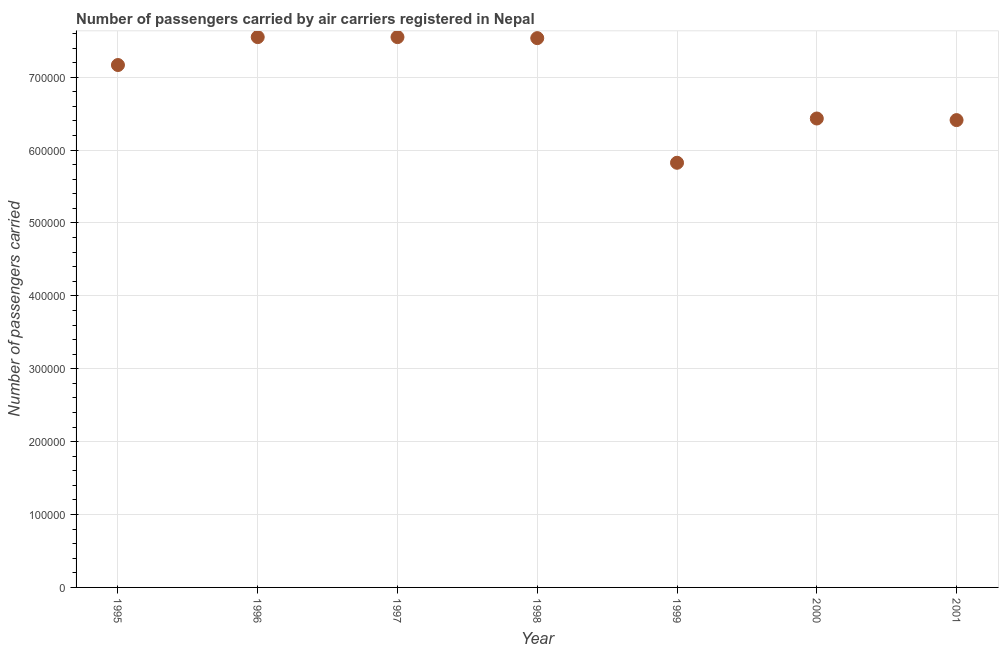What is the number of passengers carried in 2000?
Offer a terse response. 6.43e+05. Across all years, what is the maximum number of passengers carried?
Your response must be concise. 7.55e+05. Across all years, what is the minimum number of passengers carried?
Your answer should be very brief. 5.83e+05. In which year was the number of passengers carried maximum?
Keep it short and to the point. 1996. What is the sum of the number of passengers carried?
Your answer should be compact. 4.85e+06. What is the difference between the number of passengers carried in 1995 and 1997?
Give a very brief answer. -3.83e+04. What is the average number of passengers carried per year?
Ensure brevity in your answer.  6.92e+05. What is the median number of passengers carried?
Make the answer very short. 7.17e+05. Do a majority of the years between 2000 and 1997 (inclusive) have number of passengers carried greater than 620000 ?
Ensure brevity in your answer.  Yes. What is the ratio of the number of passengers carried in 1995 to that in 1999?
Provide a short and direct response. 1.23. Is the number of passengers carried in 1996 less than that in 1999?
Offer a very short reply. No. Is the difference between the number of passengers carried in 1996 and 2000 greater than the difference between any two years?
Your response must be concise. No. What is the difference between the highest and the second highest number of passengers carried?
Your answer should be very brief. 0. What is the difference between the highest and the lowest number of passengers carried?
Your answer should be very brief. 1.72e+05. Does the graph contain grids?
Provide a short and direct response. Yes. What is the title of the graph?
Keep it short and to the point. Number of passengers carried by air carriers registered in Nepal. What is the label or title of the X-axis?
Provide a succinct answer. Year. What is the label or title of the Y-axis?
Offer a very short reply. Number of passengers carried. What is the Number of passengers carried in 1995?
Offer a very short reply. 7.17e+05. What is the Number of passengers carried in 1996?
Provide a short and direct response. 7.55e+05. What is the Number of passengers carried in 1997?
Make the answer very short. 7.55e+05. What is the Number of passengers carried in 1998?
Make the answer very short. 7.54e+05. What is the Number of passengers carried in 1999?
Make the answer very short. 5.83e+05. What is the Number of passengers carried in 2000?
Ensure brevity in your answer.  6.43e+05. What is the Number of passengers carried in 2001?
Give a very brief answer. 6.41e+05. What is the difference between the Number of passengers carried in 1995 and 1996?
Provide a succinct answer. -3.83e+04. What is the difference between the Number of passengers carried in 1995 and 1997?
Your response must be concise. -3.83e+04. What is the difference between the Number of passengers carried in 1995 and 1998?
Provide a succinct answer. -3.69e+04. What is the difference between the Number of passengers carried in 1995 and 1999?
Offer a terse response. 1.34e+05. What is the difference between the Number of passengers carried in 1995 and 2000?
Offer a very short reply. 7.34e+04. What is the difference between the Number of passengers carried in 1995 and 2001?
Ensure brevity in your answer.  7.56e+04. What is the difference between the Number of passengers carried in 1996 and 1997?
Offer a very short reply. 0. What is the difference between the Number of passengers carried in 1996 and 1998?
Give a very brief answer. 1400. What is the difference between the Number of passengers carried in 1996 and 1999?
Your response must be concise. 1.72e+05. What is the difference between the Number of passengers carried in 1996 and 2000?
Offer a terse response. 1.12e+05. What is the difference between the Number of passengers carried in 1996 and 2001?
Make the answer very short. 1.14e+05. What is the difference between the Number of passengers carried in 1997 and 1998?
Your answer should be very brief. 1400. What is the difference between the Number of passengers carried in 1997 and 1999?
Make the answer very short. 1.72e+05. What is the difference between the Number of passengers carried in 1997 and 2000?
Your response must be concise. 1.12e+05. What is the difference between the Number of passengers carried in 1997 and 2001?
Your response must be concise. 1.14e+05. What is the difference between the Number of passengers carried in 1998 and 1999?
Keep it short and to the point. 1.71e+05. What is the difference between the Number of passengers carried in 1998 and 2000?
Your response must be concise. 1.10e+05. What is the difference between the Number of passengers carried in 1998 and 2001?
Your answer should be compact. 1.12e+05. What is the difference between the Number of passengers carried in 1999 and 2000?
Your answer should be compact. -6.07e+04. What is the difference between the Number of passengers carried in 1999 and 2001?
Give a very brief answer. -5.85e+04. What is the difference between the Number of passengers carried in 2000 and 2001?
Your answer should be very brief. 2190. What is the ratio of the Number of passengers carried in 1995 to that in 1996?
Offer a terse response. 0.95. What is the ratio of the Number of passengers carried in 1995 to that in 1997?
Your answer should be very brief. 0.95. What is the ratio of the Number of passengers carried in 1995 to that in 1998?
Give a very brief answer. 0.95. What is the ratio of the Number of passengers carried in 1995 to that in 1999?
Ensure brevity in your answer.  1.23. What is the ratio of the Number of passengers carried in 1995 to that in 2000?
Your response must be concise. 1.11. What is the ratio of the Number of passengers carried in 1995 to that in 2001?
Provide a short and direct response. 1.12. What is the ratio of the Number of passengers carried in 1996 to that in 1998?
Make the answer very short. 1. What is the ratio of the Number of passengers carried in 1996 to that in 1999?
Your answer should be compact. 1.3. What is the ratio of the Number of passengers carried in 1996 to that in 2000?
Give a very brief answer. 1.17. What is the ratio of the Number of passengers carried in 1996 to that in 2001?
Offer a terse response. 1.18. What is the ratio of the Number of passengers carried in 1997 to that in 1998?
Your response must be concise. 1. What is the ratio of the Number of passengers carried in 1997 to that in 1999?
Offer a very short reply. 1.3. What is the ratio of the Number of passengers carried in 1997 to that in 2000?
Ensure brevity in your answer.  1.17. What is the ratio of the Number of passengers carried in 1997 to that in 2001?
Your response must be concise. 1.18. What is the ratio of the Number of passengers carried in 1998 to that in 1999?
Make the answer very short. 1.29. What is the ratio of the Number of passengers carried in 1998 to that in 2000?
Your answer should be compact. 1.17. What is the ratio of the Number of passengers carried in 1998 to that in 2001?
Provide a succinct answer. 1.18. What is the ratio of the Number of passengers carried in 1999 to that in 2000?
Keep it short and to the point. 0.91. What is the ratio of the Number of passengers carried in 1999 to that in 2001?
Your answer should be very brief. 0.91. 